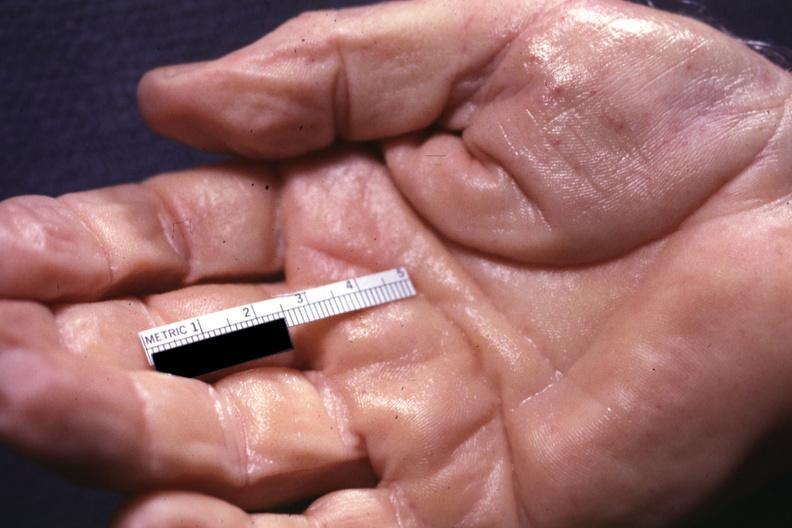re extremities present?
Answer the question using a single word or phrase. Extremities 